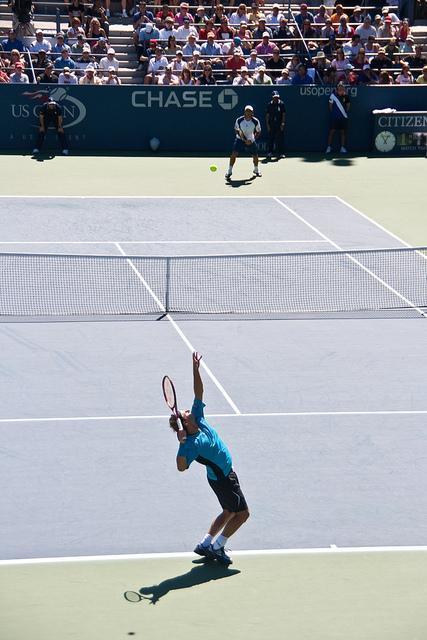How many people holding umbrellas are in the picture?
Give a very brief answer. 0. 